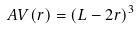<formula> <loc_0><loc_0><loc_500><loc_500>A V ( r ) = ( L - 2 r ) ^ { 3 }</formula> 